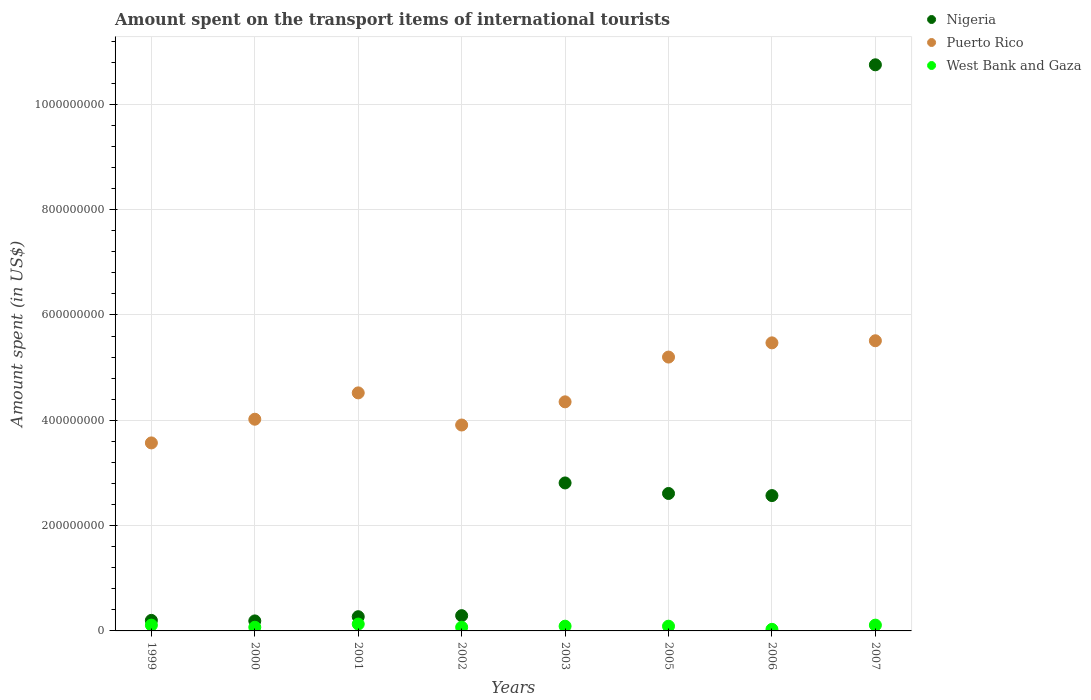Is the number of dotlines equal to the number of legend labels?
Keep it short and to the point. Yes. What is the amount spent on the transport items of international tourists in Nigeria in 1999?
Make the answer very short. 2.00e+07. Across all years, what is the maximum amount spent on the transport items of international tourists in Puerto Rico?
Your answer should be compact. 5.51e+08. In which year was the amount spent on the transport items of international tourists in Nigeria maximum?
Provide a short and direct response. 2007. In which year was the amount spent on the transport items of international tourists in West Bank and Gaza minimum?
Provide a succinct answer. 2006. What is the total amount spent on the transport items of international tourists in Nigeria in the graph?
Offer a terse response. 1.97e+09. What is the difference between the amount spent on the transport items of international tourists in Puerto Rico in 2002 and that in 2007?
Offer a very short reply. -1.60e+08. What is the difference between the amount spent on the transport items of international tourists in Nigeria in 1999 and the amount spent on the transport items of international tourists in Puerto Rico in 2005?
Provide a short and direct response. -5.00e+08. What is the average amount spent on the transport items of international tourists in Nigeria per year?
Provide a succinct answer. 2.46e+08. In the year 2002, what is the difference between the amount spent on the transport items of international tourists in West Bank and Gaza and amount spent on the transport items of international tourists in Puerto Rico?
Your response must be concise. -3.84e+08. What is the ratio of the amount spent on the transport items of international tourists in Nigeria in 2000 to that in 2005?
Your response must be concise. 0.07. What is the difference between the highest and the second highest amount spent on the transport items of international tourists in Nigeria?
Provide a short and direct response. 7.94e+08. What is the difference between the highest and the lowest amount spent on the transport items of international tourists in Puerto Rico?
Offer a very short reply. 1.94e+08. In how many years, is the amount spent on the transport items of international tourists in West Bank and Gaza greater than the average amount spent on the transport items of international tourists in West Bank and Gaza taken over all years?
Offer a terse response. 5. Is the amount spent on the transport items of international tourists in West Bank and Gaza strictly greater than the amount spent on the transport items of international tourists in Nigeria over the years?
Give a very brief answer. No. Is the amount spent on the transport items of international tourists in Puerto Rico strictly less than the amount spent on the transport items of international tourists in Nigeria over the years?
Give a very brief answer. No. Are the values on the major ticks of Y-axis written in scientific E-notation?
Give a very brief answer. No. Does the graph contain any zero values?
Keep it short and to the point. No. Does the graph contain grids?
Offer a very short reply. Yes. How are the legend labels stacked?
Your response must be concise. Vertical. What is the title of the graph?
Give a very brief answer. Amount spent on the transport items of international tourists. Does "Singapore" appear as one of the legend labels in the graph?
Your answer should be very brief. No. What is the label or title of the Y-axis?
Your answer should be very brief. Amount spent (in US$). What is the Amount spent (in US$) in Nigeria in 1999?
Make the answer very short. 2.00e+07. What is the Amount spent (in US$) in Puerto Rico in 1999?
Keep it short and to the point. 3.57e+08. What is the Amount spent (in US$) of West Bank and Gaza in 1999?
Your response must be concise. 1.10e+07. What is the Amount spent (in US$) in Nigeria in 2000?
Provide a succinct answer. 1.90e+07. What is the Amount spent (in US$) in Puerto Rico in 2000?
Provide a succinct answer. 4.02e+08. What is the Amount spent (in US$) of West Bank and Gaza in 2000?
Make the answer very short. 7.00e+06. What is the Amount spent (in US$) of Nigeria in 2001?
Keep it short and to the point. 2.70e+07. What is the Amount spent (in US$) of Puerto Rico in 2001?
Make the answer very short. 4.52e+08. What is the Amount spent (in US$) in West Bank and Gaza in 2001?
Make the answer very short. 1.30e+07. What is the Amount spent (in US$) of Nigeria in 2002?
Give a very brief answer. 2.90e+07. What is the Amount spent (in US$) in Puerto Rico in 2002?
Provide a succinct answer. 3.91e+08. What is the Amount spent (in US$) in West Bank and Gaza in 2002?
Ensure brevity in your answer.  7.00e+06. What is the Amount spent (in US$) of Nigeria in 2003?
Your response must be concise. 2.81e+08. What is the Amount spent (in US$) in Puerto Rico in 2003?
Make the answer very short. 4.35e+08. What is the Amount spent (in US$) in West Bank and Gaza in 2003?
Provide a short and direct response. 9.00e+06. What is the Amount spent (in US$) of Nigeria in 2005?
Provide a succinct answer. 2.61e+08. What is the Amount spent (in US$) in Puerto Rico in 2005?
Your answer should be very brief. 5.20e+08. What is the Amount spent (in US$) of West Bank and Gaza in 2005?
Ensure brevity in your answer.  9.00e+06. What is the Amount spent (in US$) of Nigeria in 2006?
Your answer should be very brief. 2.57e+08. What is the Amount spent (in US$) of Puerto Rico in 2006?
Your response must be concise. 5.47e+08. What is the Amount spent (in US$) in West Bank and Gaza in 2006?
Your answer should be compact. 3.00e+06. What is the Amount spent (in US$) of Nigeria in 2007?
Give a very brief answer. 1.08e+09. What is the Amount spent (in US$) of Puerto Rico in 2007?
Your response must be concise. 5.51e+08. What is the Amount spent (in US$) of West Bank and Gaza in 2007?
Ensure brevity in your answer.  1.10e+07. Across all years, what is the maximum Amount spent (in US$) of Nigeria?
Offer a very short reply. 1.08e+09. Across all years, what is the maximum Amount spent (in US$) of Puerto Rico?
Provide a short and direct response. 5.51e+08. Across all years, what is the maximum Amount spent (in US$) in West Bank and Gaza?
Offer a very short reply. 1.30e+07. Across all years, what is the minimum Amount spent (in US$) in Nigeria?
Your answer should be very brief. 1.90e+07. Across all years, what is the minimum Amount spent (in US$) in Puerto Rico?
Offer a terse response. 3.57e+08. Across all years, what is the minimum Amount spent (in US$) in West Bank and Gaza?
Keep it short and to the point. 3.00e+06. What is the total Amount spent (in US$) of Nigeria in the graph?
Your answer should be compact. 1.97e+09. What is the total Amount spent (in US$) of Puerto Rico in the graph?
Ensure brevity in your answer.  3.66e+09. What is the total Amount spent (in US$) of West Bank and Gaza in the graph?
Ensure brevity in your answer.  7.00e+07. What is the difference between the Amount spent (in US$) of Nigeria in 1999 and that in 2000?
Your answer should be very brief. 1.00e+06. What is the difference between the Amount spent (in US$) of Puerto Rico in 1999 and that in 2000?
Offer a very short reply. -4.50e+07. What is the difference between the Amount spent (in US$) in West Bank and Gaza in 1999 and that in 2000?
Offer a terse response. 4.00e+06. What is the difference between the Amount spent (in US$) of Nigeria in 1999 and that in 2001?
Your answer should be compact. -7.00e+06. What is the difference between the Amount spent (in US$) of Puerto Rico in 1999 and that in 2001?
Offer a terse response. -9.50e+07. What is the difference between the Amount spent (in US$) of West Bank and Gaza in 1999 and that in 2001?
Offer a terse response. -2.00e+06. What is the difference between the Amount spent (in US$) of Nigeria in 1999 and that in 2002?
Give a very brief answer. -9.00e+06. What is the difference between the Amount spent (in US$) in Puerto Rico in 1999 and that in 2002?
Give a very brief answer. -3.40e+07. What is the difference between the Amount spent (in US$) in Nigeria in 1999 and that in 2003?
Offer a terse response. -2.61e+08. What is the difference between the Amount spent (in US$) in Puerto Rico in 1999 and that in 2003?
Your response must be concise. -7.80e+07. What is the difference between the Amount spent (in US$) in Nigeria in 1999 and that in 2005?
Provide a succinct answer. -2.41e+08. What is the difference between the Amount spent (in US$) of Puerto Rico in 1999 and that in 2005?
Offer a very short reply. -1.63e+08. What is the difference between the Amount spent (in US$) in Nigeria in 1999 and that in 2006?
Keep it short and to the point. -2.37e+08. What is the difference between the Amount spent (in US$) in Puerto Rico in 1999 and that in 2006?
Your answer should be compact. -1.90e+08. What is the difference between the Amount spent (in US$) in West Bank and Gaza in 1999 and that in 2006?
Ensure brevity in your answer.  8.00e+06. What is the difference between the Amount spent (in US$) in Nigeria in 1999 and that in 2007?
Provide a succinct answer. -1.06e+09. What is the difference between the Amount spent (in US$) in Puerto Rico in 1999 and that in 2007?
Offer a terse response. -1.94e+08. What is the difference between the Amount spent (in US$) in West Bank and Gaza in 1999 and that in 2007?
Make the answer very short. 0. What is the difference between the Amount spent (in US$) in Nigeria in 2000 and that in 2001?
Keep it short and to the point. -8.00e+06. What is the difference between the Amount spent (in US$) of Puerto Rico in 2000 and that in 2001?
Offer a very short reply. -5.00e+07. What is the difference between the Amount spent (in US$) in West Bank and Gaza in 2000 and that in 2001?
Your answer should be compact. -6.00e+06. What is the difference between the Amount spent (in US$) in Nigeria in 2000 and that in 2002?
Your answer should be compact. -1.00e+07. What is the difference between the Amount spent (in US$) in Puerto Rico in 2000 and that in 2002?
Your answer should be very brief. 1.10e+07. What is the difference between the Amount spent (in US$) of Nigeria in 2000 and that in 2003?
Your response must be concise. -2.62e+08. What is the difference between the Amount spent (in US$) in Puerto Rico in 2000 and that in 2003?
Your answer should be compact. -3.30e+07. What is the difference between the Amount spent (in US$) of West Bank and Gaza in 2000 and that in 2003?
Your answer should be very brief. -2.00e+06. What is the difference between the Amount spent (in US$) of Nigeria in 2000 and that in 2005?
Give a very brief answer. -2.42e+08. What is the difference between the Amount spent (in US$) of Puerto Rico in 2000 and that in 2005?
Offer a terse response. -1.18e+08. What is the difference between the Amount spent (in US$) in West Bank and Gaza in 2000 and that in 2005?
Offer a terse response. -2.00e+06. What is the difference between the Amount spent (in US$) in Nigeria in 2000 and that in 2006?
Offer a terse response. -2.38e+08. What is the difference between the Amount spent (in US$) in Puerto Rico in 2000 and that in 2006?
Make the answer very short. -1.45e+08. What is the difference between the Amount spent (in US$) in Nigeria in 2000 and that in 2007?
Give a very brief answer. -1.06e+09. What is the difference between the Amount spent (in US$) of Puerto Rico in 2000 and that in 2007?
Provide a short and direct response. -1.49e+08. What is the difference between the Amount spent (in US$) of Puerto Rico in 2001 and that in 2002?
Provide a short and direct response. 6.10e+07. What is the difference between the Amount spent (in US$) of West Bank and Gaza in 2001 and that in 2002?
Offer a terse response. 6.00e+06. What is the difference between the Amount spent (in US$) of Nigeria in 2001 and that in 2003?
Keep it short and to the point. -2.54e+08. What is the difference between the Amount spent (in US$) of Puerto Rico in 2001 and that in 2003?
Provide a succinct answer. 1.70e+07. What is the difference between the Amount spent (in US$) of West Bank and Gaza in 2001 and that in 2003?
Your answer should be compact. 4.00e+06. What is the difference between the Amount spent (in US$) in Nigeria in 2001 and that in 2005?
Offer a terse response. -2.34e+08. What is the difference between the Amount spent (in US$) of Puerto Rico in 2001 and that in 2005?
Provide a succinct answer. -6.80e+07. What is the difference between the Amount spent (in US$) in West Bank and Gaza in 2001 and that in 2005?
Your response must be concise. 4.00e+06. What is the difference between the Amount spent (in US$) of Nigeria in 2001 and that in 2006?
Provide a short and direct response. -2.30e+08. What is the difference between the Amount spent (in US$) in Puerto Rico in 2001 and that in 2006?
Your answer should be very brief. -9.50e+07. What is the difference between the Amount spent (in US$) of West Bank and Gaza in 2001 and that in 2006?
Ensure brevity in your answer.  1.00e+07. What is the difference between the Amount spent (in US$) of Nigeria in 2001 and that in 2007?
Offer a very short reply. -1.05e+09. What is the difference between the Amount spent (in US$) of Puerto Rico in 2001 and that in 2007?
Ensure brevity in your answer.  -9.90e+07. What is the difference between the Amount spent (in US$) in West Bank and Gaza in 2001 and that in 2007?
Keep it short and to the point. 2.00e+06. What is the difference between the Amount spent (in US$) in Nigeria in 2002 and that in 2003?
Provide a succinct answer. -2.52e+08. What is the difference between the Amount spent (in US$) in Puerto Rico in 2002 and that in 2003?
Give a very brief answer. -4.40e+07. What is the difference between the Amount spent (in US$) of Nigeria in 2002 and that in 2005?
Your answer should be compact. -2.32e+08. What is the difference between the Amount spent (in US$) in Puerto Rico in 2002 and that in 2005?
Your answer should be very brief. -1.29e+08. What is the difference between the Amount spent (in US$) of Nigeria in 2002 and that in 2006?
Provide a short and direct response. -2.28e+08. What is the difference between the Amount spent (in US$) of Puerto Rico in 2002 and that in 2006?
Provide a succinct answer. -1.56e+08. What is the difference between the Amount spent (in US$) of West Bank and Gaza in 2002 and that in 2006?
Provide a succinct answer. 4.00e+06. What is the difference between the Amount spent (in US$) of Nigeria in 2002 and that in 2007?
Make the answer very short. -1.05e+09. What is the difference between the Amount spent (in US$) in Puerto Rico in 2002 and that in 2007?
Your answer should be very brief. -1.60e+08. What is the difference between the Amount spent (in US$) of Puerto Rico in 2003 and that in 2005?
Provide a short and direct response. -8.50e+07. What is the difference between the Amount spent (in US$) of West Bank and Gaza in 2003 and that in 2005?
Ensure brevity in your answer.  0. What is the difference between the Amount spent (in US$) of Nigeria in 2003 and that in 2006?
Your answer should be very brief. 2.40e+07. What is the difference between the Amount spent (in US$) in Puerto Rico in 2003 and that in 2006?
Make the answer very short. -1.12e+08. What is the difference between the Amount spent (in US$) in West Bank and Gaza in 2003 and that in 2006?
Offer a very short reply. 6.00e+06. What is the difference between the Amount spent (in US$) of Nigeria in 2003 and that in 2007?
Keep it short and to the point. -7.94e+08. What is the difference between the Amount spent (in US$) of Puerto Rico in 2003 and that in 2007?
Provide a short and direct response. -1.16e+08. What is the difference between the Amount spent (in US$) of West Bank and Gaza in 2003 and that in 2007?
Offer a terse response. -2.00e+06. What is the difference between the Amount spent (in US$) of Nigeria in 2005 and that in 2006?
Offer a terse response. 4.00e+06. What is the difference between the Amount spent (in US$) in Puerto Rico in 2005 and that in 2006?
Offer a terse response. -2.70e+07. What is the difference between the Amount spent (in US$) in Nigeria in 2005 and that in 2007?
Your answer should be compact. -8.14e+08. What is the difference between the Amount spent (in US$) in Puerto Rico in 2005 and that in 2007?
Offer a very short reply. -3.10e+07. What is the difference between the Amount spent (in US$) in West Bank and Gaza in 2005 and that in 2007?
Your answer should be compact. -2.00e+06. What is the difference between the Amount spent (in US$) in Nigeria in 2006 and that in 2007?
Give a very brief answer. -8.18e+08. What is the difference between the Amount spent (in US$) of West Bank and Gaza in 2006 and that in 2007?
Provide a short and direct response. -8.00e+06. What is the difference between the Amount spent (in US$) of Nigeria in 1999 and the Amount spent (in US$) of Puerto Rico in 2000?
Offer a terse response. -3.82e+08. What is the difference between the Amount spent (in US$) in Nigeria in 1999 and the Amount spent (in US$) in West Bank and Gaza in 2000?
Give a very brief answer. 1.30e+07. What is the difference between the Amount spent (in US$) of Puerto Rico in 1999 and the Amount spent (in US$) of West Bank and Gaza in 2000?
Your answer should be very brief. 3.50e+08. What is the difference between the Amount spent (in US$) of Nigeria in 1999 and the Amount spent (in US$) of Puerto Rico in 2001?
Ensure brevity in your answer.  -4.32e+08. What is the difference between the Amount spent (in US$) in Nigeria in 1999 and the Amount spent (in US$) in West Bank and Gaza in 2001?
Provide a short and direct response. 7.00e+06. What is the difference between the Amount spent (in US$) of Puerto Rico in 1999 and the Amount spent (in US$) of West Bank and Gaza in 2001?
Your response must be concise. 3.44e+08. What is the difference between the Amount spent (in US$) in Nigeria in 1999 and the Amount spent (in US$) in Puerto Rico in 2002?
Give a very brief answer. -3.71e+08. What is the difference between the Amount spent (in US$) in Nigeria in 1999 and the Amount spent (in US$) in West Bank and Gaza in 2002?
Your answer should be compact. 1.30e+07. What is the difference between the Amount spent (in US$) in Puerto Rico in 1999 and the Amount spent (in US$) in West Bank and Gaza in 2002?
Your response must be concise. 3.50e+08. What is the difference between the Amount spent (in US$) of Nigeria in 1999 and the Amount spent (in US$) of Puerto Rico in 2003?
Offer a very short reply. -4.15e+08. What is the difference between the Amount spent (in US$) in Nigeria in 1999 and the Amount spent (in US$) in West Bank and Gaza in 2003?
Your answer should be compact. 1.10e+07. What is the difference between the Amount spent (in US$) of Puerto Rico in 1999 and the Amount spent (in US$) of West Bank and Gaza in 2003?
Ensure brevity in your answer.  3.48e+08. What is the difference between the Amount spent (in US$) of Nigeria in 1999 and the Amount spent (in US$) of Puerto Rico in 2005?
Your response must be concise. -5.00e+08. What is the difference between the Amount spent (in US$) of Nigeria in 1999 and the Amount spent (in US$) of West Bank and Gaza in 2005?
Ensure brevity in your answer.  1.10e+07. What is the difference between the Amount spent (in US$) in Puerto Rico in 1999 and the Amount spent (in US$) in West Bank and Gaza in 2005?
Provide a short and direct response. 3.48e+08. What is the difference between the Amount spent (in US$) of Nigeria in 1999 and the Amount spent (in US$) of Puerto Rico in 2006?
Your answer should be very brief. -5.27e+08. What is the difference between the Amount spent (in US$) in Nigeria in 1999 and the Amount spent (in US$) in West Bank and Gaza in 2006?
Provide a succinct answer. 1.70e+07. What is the difference between the Amount spent (in US$) of Puerto Rico in 1999 and the Amount spent (in US$) of West Bank and Gaza in 2006?
Ensure brevity in your answer.  3.54e+08. What is the difference between the Amount spent (in US$) of Nigeria in 1999 and the Amount spent (in US$) of Puerto Rico in 2007?
Your answer should be very brief. -5.31e+08. What is the difference between the Amount spent (in US$) of Nigeria in 1999 and the Amount spent (in US$) of West Bank and Gaza in 2007?
Offer a very short reply. 9.00e+06. What is the difference between the Amount spent (in US$) in Puerto Rico in 1999 and the Amount spent (in US$) in West Bank and Gaza in 2007?
Keep it short and to the point. 3.46e+08. What is the difference between the Amount spent (in US$) in Nigeria in 2000 and the Amount spent (in US$) in Puerto Rico in 2001?
Make the answer very short. -4.33e+08. What is the difference between the Amount spent (in US$) in Puerto Rico in 2000 and the Amount spent (in US$) in West Bank and Gaza in 2001?
Your answer should be compact. 3.89e+08. What is the difference between the Amount spent (in US$) of Nigeria in 2000 and the Amount spent (in US$) of Puerto Rico in 2002?
Offer a terse response. -3.72e+08. What is the difference between the Amount spent (in US$) of Nigeria in 2000 and the Amount spent (in US$) of West Bank and Gaza in 2002?
Your response must be concise. 1.20e+07. What is the difference between the Amount spent (in US$) in Puerto Rico in 2000 and the Amount spent (in US$) in West Bank and Gaza in 2002?
Give a very brief answer. 3.95e+08. What is the difference between the Amount spent (in US$) in Nigeria in 2000 and the Amount spent (in US$) in Puerto Rico in 2003?
Your response must be concise. -4.16e+08. What is the difference between the Amount spent (in US$) in Puerto Rico in 2000 and the Amount spent (in US$) in West Bank and Gaza in 2003?
Ensure brevity in your answer.  3.93e+08. What is the difference between the Amount spent (in US$) of Nigeria in 2000 and the Amount spent (in US$) of Puerto Rico in 2005?
Offer a very short reply. -5.01e+08. What is the difference between the Amount spent (in US$) in Nigeria in 2000 and the Amount spent (in US$) in West Bank and Gaza in 2005?
Offer a terse response. 1.00e+07. What is the difference between the Amount spent (in US$) of Puerto Rico in 2000 and the Amount spent (in US$) of West Bank and Gaza in 2005?
Keep it short and to the point. 3.93e+08. What is the difference between the Amount spent (in US$) in Nigeria in 2000 and the Amount spent (in US$) in Puerto Rico in 2006?
Your answer should be very brief. -5.28e+08. What is the difference between the Amount spent (in US$) of Nigeria in 2000 and the Amount spent (in US$) of West Bank and Gaza in 2006?
Your answer should be very brief. 1.60e+07. What is the difference between the Amount spent (in US$) of Puerto Rico in 2000 and the Amount spent (in US$) of West Bank and Gaza in 2006?
Make the answer very short. 3.99e+08. What is the difference between the Amount spent (in US$) in Nigeria in 2000 and the Amount spent (in US$) in Puerto Rico in 2007?
Ensure brevity in your answer.  -5.32e+08. What is the difference between the Amount spent (in US$) in Nigeria in 2000 and the Amount spent (in US$) in West Bank and Gaza in 2007?
Keep it short and to the point. 8.00e+06. What is the difference between the Amount spent (in US$) in Puerto Rico in 2000 and the Amount spent (in US$) in West Bank and Gaza in 2007?
Your answer should be compact. 3.91e+08. What is the difference between the Amount spent (in US$) in Nigeria in 2001 and the Amount spent (in US$) in Puerto Rico in 2002?
Make the answer very short. -3.64e+08. What is the difference between the Amount spent (in US$) in Puerto Rico in 2001 and the Amount spent (in US$) in West Bank and Gaza in 2002?
Ensure brevity in your answer.  4.45e+08. What is the difference between the Amount spent (in US$) of Nigeria in 2001 and the Amount spent (in US$) of Puerto Rico in 2003?
Provide a short and direct response. -4.08e+08. What is the difference between the Amount spent (in US$) of Nigeria in 2001 and the Amount spent (in US$) of West Bank and Gaza in 2003?
Give a very brief answer. 1.80e+07. What is the difference between the Amount spent (in US$) of Puerto Rico in 2001 and the Amount spent (in US$) of West Bank and Gaza in 2003?
Ensure brevity in your answer.  4.43e+08. What is the difference between the Amount spent (in US$) of Nigeria in 2001 and the Amount spent (in US$) of Puerto Rico in 2005?
Offer a very short reply. -4.93e+08. What is the difference between the Amount spent (in US$) of Nigeria in 2001 and the Amount spent (in US$) of West Bank and Gaza in 2005?
Provide a succinct answer. 1.80e+07. What is the difference between the Amount spent (in US$) of Puerto Rico in 2001 and the Amount spent (in US$) of West Bank and Gaza in 2005?
Keep it short and to the point. 4.43e+08. What is the difference between the Amount spent (in US$) of Nigeria in 2001 and the Amount spent (in US$) of Puerto Rico in 2006?
Offer a very short reply. -5.20e+08. What is the difference between the Amount spent (in US$) in Nigeria in 2001 and the Amount spent (in US$) in West Bank and Gaza in 2006?
Offer a very short reply. 2.40e+07. What is the difference between the Amount spent (in US$) in Puerto Rico in 2001 and the Amount spent (in US$) in West Bank and Gaza in 2006?
Provide a succinct answer. 4.49e+08. What is the difference between the Amount spent (in US$) in Nigeria in 2001 and the Amount spent (in US$) in Puerto Rico in 2007?
Ensure brevity in your answer.  -5.24e+08. What is the difference between the Amount spent (in US$) in Nigeria in 2001 and the Amount spent (in US$) in West Bank and Gaza in 2007?
Your response must be concise. 1.60e+07. What is the difference between the Amount spent (in US$) in Puerto Rico in 2001 and the Amount spent (in US$) in West Bank and Gaza in 2007?
Your response must be concise. 4.41e+08. What is the difference between the Amount spent (in US$) in Nigeria in 2002 and the Amount spent (in US$) in Puerto Rico in 2003?
Provide a short and direct response. -4.06e+08. What is the difference between the Amount spent (in US$) of Nigeria in 2002 and the Amount spent (in US$) of West Bank and Gaza in 2003?
Offer a terse response. 2.00e+07. What is the difference between the Amount spent (in US$) in Puerto Rico in 2002 and the Amount spent (in US$) in West Bank and Gaza in 2003?
Give a very brief answer. 3.82e+08. What is the difference between the Amount spent (in US$) in Nigeria in 2002 and the Amount spent (in US$) in Puerto Rico in 2005?
Ensure brevity in your answer.  -4.91e+08. What is the difference between the Amount spent (in US$) in Nigeria in 2002 and the Amount spent (in US$) in West Bank and Gaza in 2005?
Ensure brevity in your answer.  2.00e+07. What is the difference between the Amount spent (in US$) in Puerto Rico in 2002 and the Amount spent (in US$) in West Bank and Gaza in 2005?
Offer a terse response. 3.82e+08. What is the difference between the Amount spent (in US$) of Nigeria in 2002 and the Amount spent (in US$) of Puerto Rico in 2006?
Give a very brief answer. -5.18e+08. What is the difference between the Amount spent (in US$) in Nigeria in 2002 and the Amount spent (in US$) in West Bank and Gaza in 2006?
Provide a short and direct response. 2.60e+07. What is the difference between the Amount spent (in US$) of Puerto Rico in 2002 and the Amount spent (in US$) of West Bank and Gaza in 2006?
Give a very brief answer. 3.88e+08. What is the difference between the Amount spent (in US$) in Nigeria in 2002 and the Amount spent (in US$) in Puerto Rico in 2007?
Give a very brief answer. -5.22e+08. What is the difference between the Amount spent (in US$) of Nigeria in 2002 and the Amount spent (in US$) of West Bank and Gaza in 2007?
Give a very brief answer. 1.80e+07. What is the difference between the Amount spent (in US$) of Puerto Rico in 2002 and the Amount spent (in US$) of West Bank and Gaza in 2007?
Your response must be concise. 3.80e+08. What is the difference between the Amount spent (in US$) in Nigeria in 2003 and the Amount spent (in US$) in Puerto Rico in 2005?
Your answer should be compact. -2.39e+08. What is the difference between the Amount spent (in US$) of Nigeria in 2003 and the Amount spent (in US$) of West Bank and Gaza in 2005?
Keep it short and to the point. 2.72e+08. What is the difference between the Amount spent (in US$) in Puerto Rico in 2003 and the Amount spent (in US$) in West Bank and Gaza in 2005?
Offer a terse response. 4.26e+08. What is the difference between the Amount spent (in US$) in Nigeria in 2003 and the Amount spent (in US$) in Puerto Rico in 2006?
Provide a short and direct response. -2.66e+08. What is the difference between the Amount spent (in US$) of Nigeria in 2003 and the Amount spent (in US$) of West Bank and Gaza in 2006?
Your response must be concise. 2.78e+08. What is the difference between the Amount spent (in US$) of Puerto Rico in 2003 and the Amount spent (in US$) of West Bank and Gaza in 2006?
Keep it short and to the point. 4.32e+08. What is the difference between the Amount spent (in US$) of Nigeria in 2003 and the Amount spent (in US$) of Puerto Rico in 2007?
Offer a very short reply. -2.70e+08. What is the difference between the Amount spent (in US$) in Nigeria in 2003 and the Amount spent (in US$) in West Bank and Gaza in 2007?
Give a very brief answer. 2.70e+08. What is the difference between the Amount spent (in US$) in Puerto Rico in 2003 and the Amount spent (in US$) in West Bank and Gaza in 2007?
Keep it short and to the point. 4.24e+08. What is the difference between the Amount spent (in US$) in Nigeria in 2005 and the Amount spent (in US$) in Puerto Rico in 2006?
Keep it short and to the point. -2.86e+08. What is the difference between the Amount spent (in US$) of Nigeria in 2005 and the Amount spent (in US$) of West Bank and Gaza in 2006?
Your response must be concise. 2.58e+08. What is the difference between the Amount spent (in US$) of Puerto Rico in 2005 and the Amount spent (in US$) of West Bank and Gaza in 2006?
Your answer should be very brief. 5.17e+08. What is the difference between the Amount spent (in US$) of Nigeria in 2005 and the Amount spent (in US$) of Puerto Rico in 2007?
Give a very brief answer. -2.90e+08. What is the difference between the Amount spent (in US$) in Nigeria in 2005 and the Amount spent (in US$) in West Bank and Gaza in 2007?
Your answer should be very brief. 2.50e+08. What is the difference between the Amount spent (in US$) of Puerto Rico in 2005 and the Amount spent (in US$) of West Bank and Gaza in 2007?
Your response must be concise. 5.09e+08. What is the difference between the Amount spent (in US$) of Nigeria in 2006 and the Amount spent (in US$) of Puerto Rico in 2007?
Offer a terse response. -2.94e+08. What is the difference between the Amount spent (in US$) in Nigeria in 2006 and the Amount spent (in US$) in West Bank and Gaza in 2007?
Provide a short and direct response. 2.46e+08. What is the difference between the Amount spent (in US$) in Puerto Rico in 2006 and the Amount spent (in US$) in West Bank and Gaza in 2007?
Give a very brief answer. 5.36e+08. What is the average Amount spent (in US$) of Nigeria per year?
Your answer should be very brief. 2.46e+08. What is the average Amount spent (in US$) of Puerto Rico per year?
Your answer should be compact. 4.57e+08. What is the average Amount spent (in US$) of West Bank and Gaza per year?
Your answer should be very brief. 8.75e+06. In the year 1999, what is the difference between the Amount spent (in US$) in Nigeria and Amount spent (in US$) in Puerto Rico?
Provide a succinct answer. -3.37e+08. In the year 1999, what is the difference between the Amount spent (in US$) in Nigeria and Amount spent (in US$) in West Bank and Gaza?
Provide a short and direct response. 9.00e+06. In the year 1999, what is the difference between the Amount spent (in US$) of Puerto Rico and Amount spent (in US$) of West Bank and Gaza?
Keep it short and to the point. 3.46e+08. In the year 2000, what is the difference between the Amount spent (in US$) in Nigeria and Amount spent (in US$) in Puerto Rico?
Provide a short and direct response. -3.83e+08. In the year 2000, what is the difference between the Amount spent (in US$) in Puerto Rico and Amount spent (in US$) in West Bank and Gaza?
Make the answer very short. 3.95e+08. In the year 2001, what is the difference between the Amount spent (in US$) in Nigeria and Amount spent (in US$) in Puerto Rico?
Your response must be concise. -4.25e+08. In the year 2001, what is the difference between the Amount spent (in US$) of Nigeria and Amount spent (in US$) of West Bank and Gaza?
Provide a succinct answer. 1.40e+07. In the year 2001, what is the difference between the Amount spent (in US$) in Puerto Rico and Amount spent (in US$) in West Bank and Gaza?
Offer a very short reply. 4.39e+08. In the year 2002, what is the difference between the Amount spent (in US$) in Nigeria and Amount spent (in US$) in Puerto Rico?
Offer a very short reply. -3.62e+08. In the year 2002, what is the difference between the Amount spent (in US$) in Nigeria and Amount spent (in US$) in West Bank and Gaza?
Provide a short and direct response. 2.20e+07. In the year 2002, what is the difference between the Amount spent (in US$) of Puerto Rico and Amount spent (in US$) of West Bank and Gaza?
Provide a short and direct response. 3.84e+08. In the year 2003, what is the difference between the Amount spent (in US$) in Nigeria and Amount spent (in US$) in Puerto Rico?
Ensure brevity in your answer.  -1.54e+08. In the year 2003, what is the difference between the Amount spent (in US$) in Nigeria and Amount spent (in US$) in West Bank and Gaza?
Your answer should be very brief. 2.72e+08. In the year 2003, what is the difference between the Amount spent (in US$) in Puerto Rico and Amount spent (in US$) in West Bank and Gaza?
Ensure brevity in your answer.  4.26e+08. In the year 2005, what is the difference between the Amount spent (in US$) of Nigeria and Amount spent (in US$) of Puerto Rico?
Provide a short and direct response. -2.59e+08. In the year 2005, what is the difference between the Amount spent (in US$) of Nigeria and Amount spent (in US$) of West Bank and Gaza?
Offer a terse response. 2.52e+08. In the year 2005, what is the difference between the Amount spent (in US$) in Puerto Rico and Amount spent (in US$) in West Bank and Gaza?
Offer a terse response. 5.11e+08. In the year 2006, what is the difference between the Amount spent (in US$) of Nigeria and Amount spent (in US$) of Puerto Rico?
Keep it short and to the point. -2.90e+08. In the year 2006, what is the difference between the Amount spent (in US$) in Nigeria and Amount spent (in US$) in West Bank and Gaza?
Make the answer very short. 2.54e+08. In the year 2006, what is the difference between the Amount spent (in US$) of Puerto Rico and Amount spent (in US$) of West Bank and Gaza?
Provide a short and direct response. 5.44e+08. In the year 2007, what is the difference between the Amount spent (in US$) in Nigeria and Amount spent (in US$) in Puerto Rico?
Ensure brevity in your answer.  5.24e+08. In the year 2007, what is the difference between the Amount spent (in US$) in Nigeria and Amount spent (in US$) in West Bank and Gaza?
Your response must be concise. 1.06e+09. In the year 2007, what is the difference between the Amount spent (in US$) in Puerto Rico and Amount spent (in US$) in West Bank and Gaza?
Keep it short and to the point. 5.40e+08. What is the ratio of the Amount spent (in US$) of Nigeria in 1999 to that in 2000?
Your response must be concise. 1.05. What is the ratio of the Amount spent (in US$) in Puerto Rico in 1999 to that in 2000?
Offer a very short reply. 0.89. What is the ratio of the Amount spent (in US$) of West Bank and Gaza in 1999 to that in 2000?
Make the answer very short. 1.57. What is the ratio of the Amount spent (in US$) of Nigeria in 1999 to that in 2001?
Provide a short and direct response. 0.74. What is the ratio of the Amount spent (in US$) of Puerto Rico in 1999 to that in 2001?
Make the answer very short. 0.79. What is the ratio of the Amount spent (in US$) in West Bank and Gaza in 1999 to that in 2001?
Provide a short and direct response. 0.85. What is the ratio of the Amount spent (in US$) in Nigeria in 1999 to that in 2002?
Offer a very short reply. 0.69. What is the ratio of the Amount spent (in US$) of West Bank and Gaza in 1999 to that in 2002?
Your answer should be compact. 1.57. What is the ratio of the Amount spent (in US$) of Nigeria in 1999 to that in 2003?
Provide a succinct answer. 0.07. What is the ratio of the Amount spent (in US$) of Puerto Rico in 1999 to that in 2003?
Keep it short and to the point. 0.82. What is the ratio of the Amount spent (in US$) in West Bank and Gaza in 1999 to that in 2003?
Offer a very short reply. 1.22. What is the ratio of the Amount spent (in US$) of Nigeria in 1999 to that in 2005?
Keep it short and to the point. 0.08. What is the ratio of the Amount spent (in US$) of Puerto Rico in 1999 to that in 2005?
Your response must be concise. 0.69. What is the ratio of the Amount spent (in US$) of West Bank and Gaza in 1999 to that in 2005?
Ensure brevity in your answer.  1.22. What is the ratio of the Amount spent (in US$) of Nigeria in 1999 to that in 2006?
Give a very brief answer. 0.08. What is the ratio of the Amount spent (in US$) of Puerto Rico in 1999 to that in 2006?
Make the answer very short. 0.65. What is the ratio of the Amount spent (in US$) in West Bank and Gaza in 1999 to that in 2006?
Your response must be concise. 3.67. What is the ratio of the Amount spent (in US$) in Nigeria in 1999 to that in 2007?
Your answer should be compact. 0.02. What is the ratio of the Amount spent (in US$) in Puerto Rico in 1999 to that in 2007?
Your response must be concise. 0.65. What is the ratio of the Amount spent (in US$) of West Bank and Gaza in 1999 to that in 2007?
Provide a succinct answer. 1. What is the ratio of the Amount spent (in US$) of Nigeria in 2000 to that in 2001?
Your answer should be very brief. 0.7. What is the ratio of the Amount spent (in US$) in Puerto Rico in 2000 to that in 2001?
Keep it short and to the point. 0.89. What is the ratio of the Amount spent (in US$) of West Bank and Gaza in 2000 to that in 2001?
Your answer should be very brief. 0.54. What is the ratio of the Amount spent (in US$) in Nigeria in 2000 to that in 2002?
Keep it short and to the point. 0.66. What is the ratio of the Amount spent (in US$) in Puerto Rico in 2000 to that in 2002?
Ensure brevity in your answer.  1.03. What is the ratio of the Amount spent (in US$) in Nigeria in 2000 to that in 2003?
Provide a succinct answer. 0.07. What is the ratio of the Amount spent (in US$) in Puerto Rico in 2000 to that in 2003?
Provide a succinct answer. 0.92. What is the ratio of the Amount spent (in US$) in Nigeria in 2000 to that in 2005?
Provide a succinct answer. 0.07. What is the ratio of the Amount spent (in US$) of Puerto Rico in 2000 to that in 2005?
Provide a short and direct response. 0.77. What is the ratio of the Amount spent (in US$) in West Bank and Gaza in 2000 to that in 2005?
Provide a succinct answer. 0.78. What is the ratio of the Amount spent (in US$) of Nigeria in 2000 to that in 2006?
Offer a very short reply. 0.07. What is the ratio of the Amount spent (in US$) in Puerto Rico in 2000 to that in 2006?
Keep it short and to the point. 0.73. What is the ratio of the Amount spent (in US$) of West Bank and Gaza in 2000 to that in 2006?
Your response must be concise. 2.33. What is the ratio of the Amount spent (in US$) of Nigeria in 2000 to that in 2007?
Provide a short and direct response. 0.02. What is the ratio of the Amount spent (in US$) of Puerto Rico in 2000 to that in 2007?
Provide a short and direct response. 0.73. What is the ratio of the Amount spent (in US$) of West Bank and Gaza in 2000 to that in 2007?
Your response must be concise. 0.64. What is the ratio of the Amount spent (in US$) of Nigeria in 2001 to that in 2002?
Your response must be concise. 0.93. What is the ratio of the Amount spent (in US$) of Puerto Rico in 2001 to that in 2002?
Ensure brevity in your answer.  1.16. What is the ratio of the Amount spent (in US$) in West Bank and Gaza in 2001 to that in 2002?
Give a very brief answer. 1.86. What is the ratio of the Amount spent (in US$) of Nigeria in 2001 to that in 2003?
Offer a terse response. 0.1. What is the ratio of the Amount spent (in US$) in Puerto Rico in 2001 to that in 2003?
Your answer should be compact. 1.04. What is the ratio of the Amount spent (in US$) in West Bank and Gaza in 2001 to that in 2003?
Offer a terse response. 1.44. What is the ratio of the Amount spent (in US$) in Nigeria in 2001 to that in 2005?
Keep it short and to the point. 0.1. What is the ratio of the Amount spent (in US$) of Puerto Rico in 2001 to that in 2005?
Ensure brevity in your answer.  0.87. What is the ratio of the Amount spent (in US$) in West Bank and Gaza in 2001 to that in 2005?
Give a very brief answer. 1.44. What is the ratio of the Amount spent (in US$) in Nigeria in 2001 to that in 2006?
Your answer should be compact. 0.11. What is the ratio of the Amount spent (in US$) of Puerto Rico in 2001 to that in 2006?
Make the answer very short. 0.83. What is the ratio of the Amount spent (in US$) of West Bank and Gaza in 2001 to that in 2006?
Provide a short and direct response. 4.33. What is the ratio of the Amount spent (in US$) in Nigeria in 2001 to that in 2007?
Offer a terse response. 0.03. What is the ratio of the Amount spent (in US$) in Puerto Rico in 2001 to that in 2007?
Offer a very short reply. 0.82. What is the ratio of the Amount spent (in US$) of West Bank and Gaza in 2001 to that in 2007?
Give a very brief answer. 1.18. What is the ratio of the Amount spent (in US$) of Nigeria in 2002 to that in 2003?
Offer a terse response. 0.1. What is the ratio of the Amount spent (in US$) in Puerto Rico in 2002 to that in 2003?
Make the answer very short. 0.9. What is the ratio of the Amount spent (in US$) of Puerto Rico in 2002 to that in 2005?
Your answer should be very brief. 0.75. What is the ratio of the Amount spent (in US$) of West Bank and Gaza in 2002 to that in 2005?
Keep it short and to the point. 0.78. What is the ratio of the Amount spent (in US$) of Nigeria in 2002 to that in 2006?
Your answer should be compact. 0.11. What is the ratio of the Amount spent (in US$) of Puerto Rico in 2002 to that in 2006?
Your answer should be compact. 0.71. What is the ratio of the Amount spent (in US$) of West Bank and Gaza in 2002 to that in 2006?
Provide a short and direct response. 2.33. What is the ratio of the Amount spent (in US$) of Nigeria in 2002 to that in 2007?
Provide a succinct answer. 0.03. What is the ratio of the Amount spent (in US$) in Puerto Rico in 2002 to that in 2007?
Provide a succinct answer. 0.71. What is the ratio of the Amount spent (in US$) of West Bank and Gaza in 2002 to that in 2007?
Give a very brief answer. 0.64. What is the ratio of the Amount spent (in US$) of Nigeria in 2003 to that in 2005?
Provide a succinct answer. 1.08. What is the ratio of the Amount spent (in US$) in Puerto Rico in 2003 to that in 2005?
Provide a short and direct response. 0.84. What is the ratio of the Amount spent (in US$) of West Bank and Gaza in 2003 to that in 2005?
Your answer should be very brief. 1. What is the ratio of the Amount spent (in US$) of Nigeria in 2003 to that in 2006?
Provide a short and direct response. 1.09. What is the ratio of the Amount spent (in US$) of Puerto Rico in 2003 to that in 2006?
Offer a terse response. 0.8. What is the ratio of the Amount spent (in US$) of Nigeria in 2003 to that in 2007?
Make the answer very short. 0.26. What is the ratio of the Amount spent (in US$) in Puerto Rico in 2003 to that in 2007?
Offer a terse response. 0.79. What is the ratio of the Amount spent (in US$) of West Bank and Gaza in 2003 to that in 2007?
Your answer should be compact. 0.82. What is the ratio of the Amount spent (in US$) in Nigeria in 2005 to that in 2006?
Ensure brevity in your answer.  1.02. What is the ratio of the Amount spent (in US$) of Puerto Rico in 2005 to that in 2006?
Provide a succinct answer. 0.95. What is the ratio of the Amount spent (in US$) of Nigeria in 2005 to that in 2007?
Provide a short and direct response. 0.24. What is the ratio of the Amount spent (in US$) in Puerto Rico in 2005 to that in 2007?
Keep it short and to the point. 0.94. What is the ratio of the Amount spent (in US$) in West Bank and Gaza in 2005 to that in 2007?
Provide a short and direct response. 0.82. What is the ratio of the Amount spent (in US$) in Nigeria in 2006 to that in 2007?
Your answer should be compact. 0.24. What is the ratio of the Amount spent (in US$) in West Bank and Gaza in 2006 to that in 2007?
Your response must be concise. 0.27. What is the difference between the highest and the second highest Amount spent (in US$) in Nigeria?
Your answer should be very brief. 7.94e+08. What is the difference between the highest and the lowest Amount spent (in US$) of Nigeria?
Make the answer very short. 1.06e+09. What is the difference between the highest and the lowest Amount spent (in US$) in Puerto Rico?
Provide a succinct answer. 1.94e+08. What is the difference between the highest and the lowest Amount spent (in US$) of West Bank and Gaza?
Provide a short and direct response. 1.00e+07. 